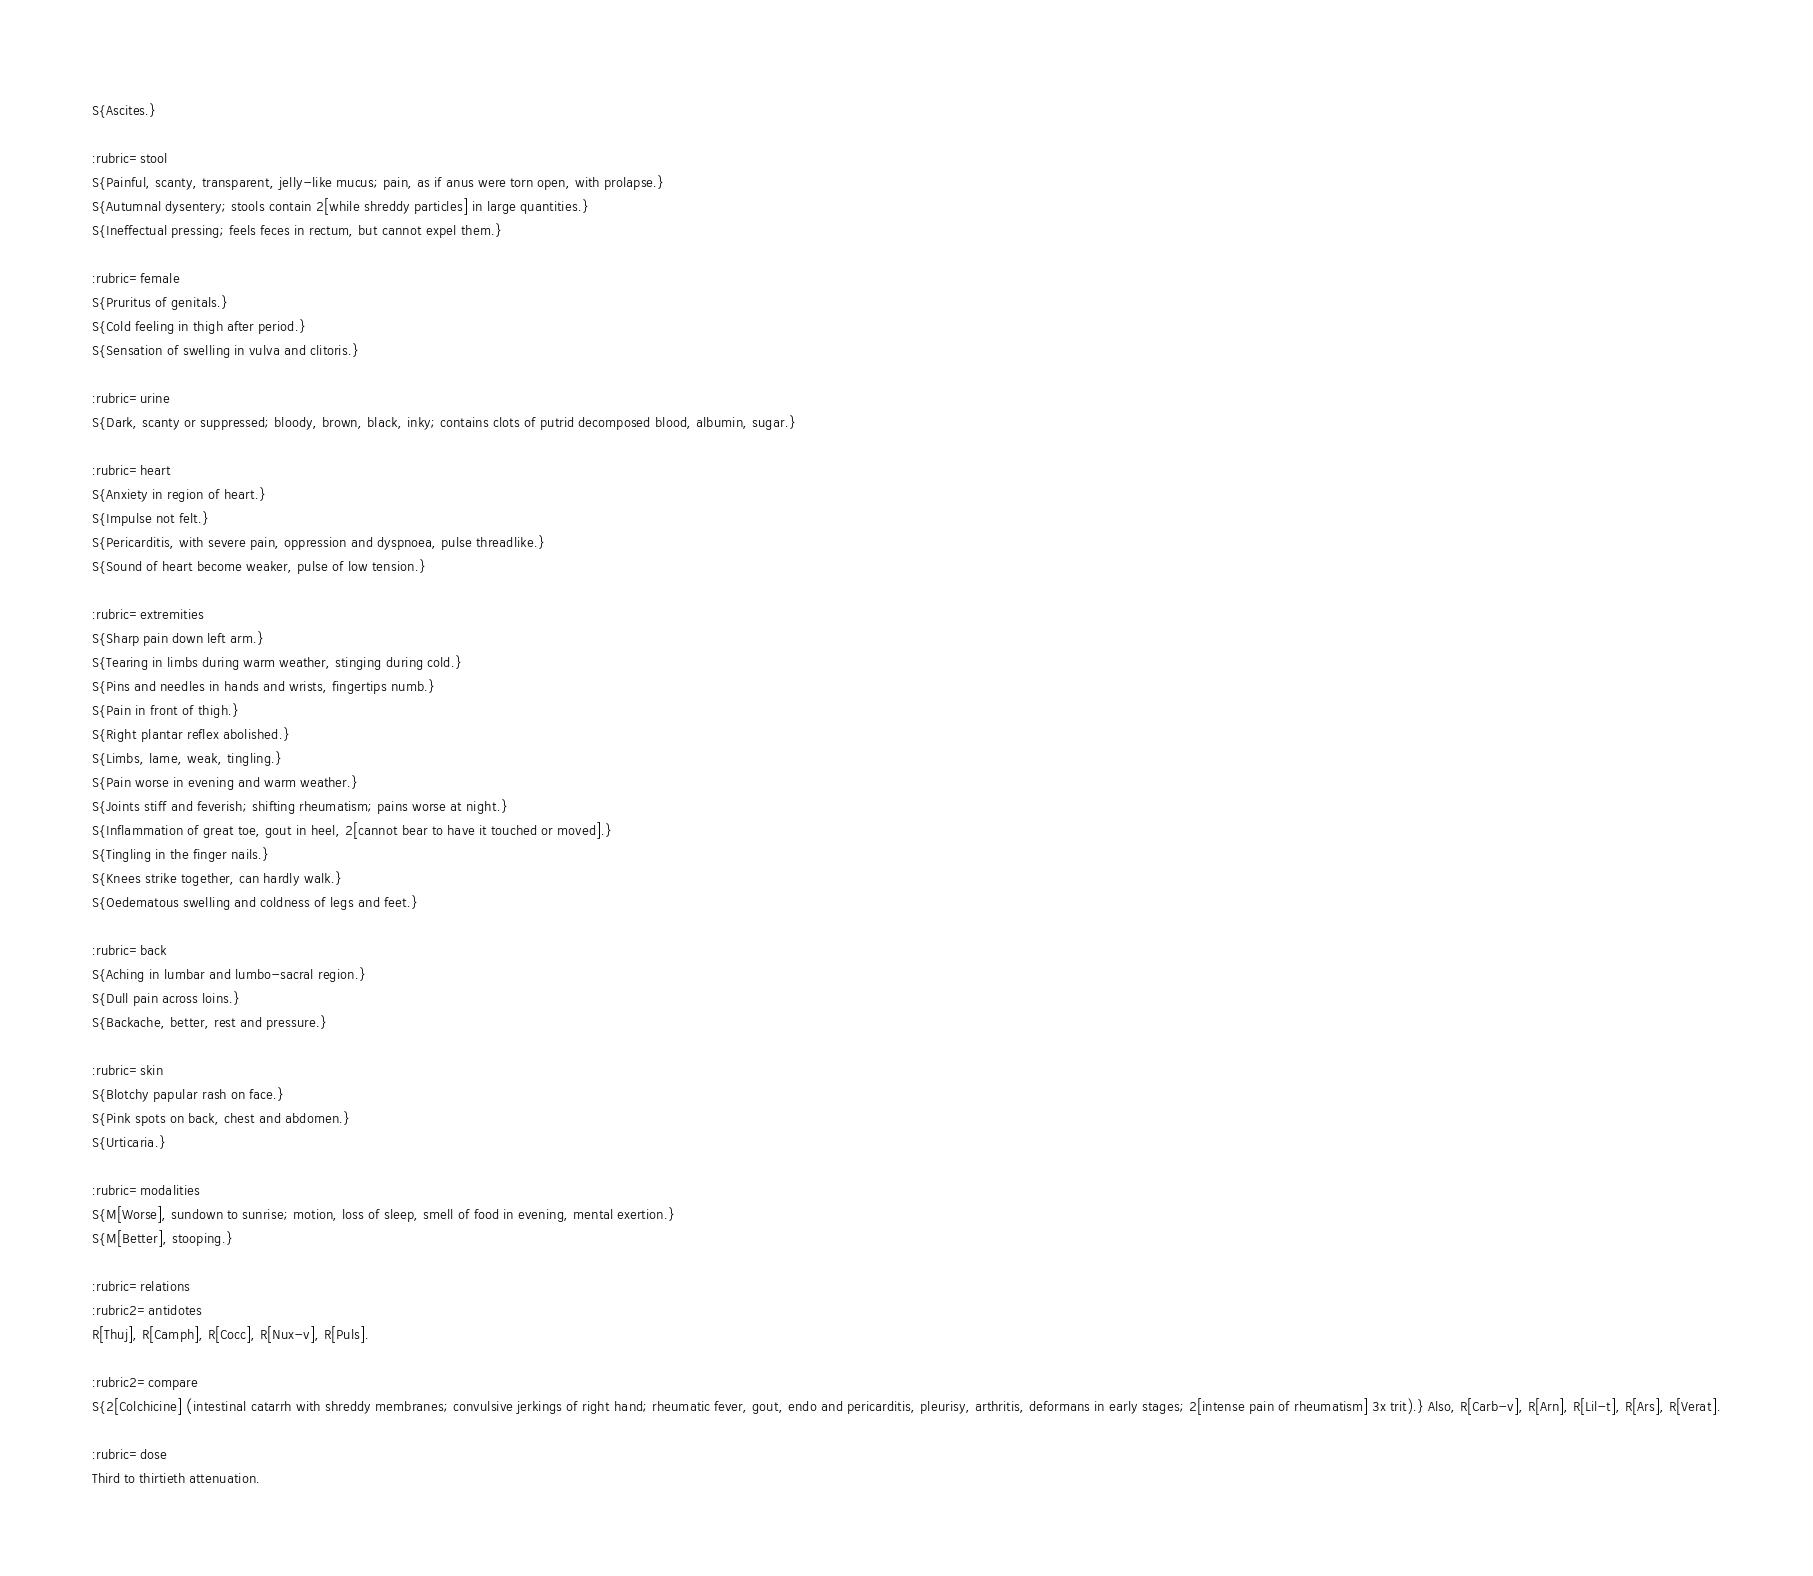<code> <loc_0><loc_0><loc_500><loc_500><_ObjectiveC_>S{Ascites.}

:rubric=stool
S{Painful, scanty, transparent, jelly-like mucus; pain, as if anus were torn open, with prolapse.}
S{Autumnal dysentery; stools contain 2[while shreddy particles] in large quantities.}
S{Ineffectual pressing; feels feces in rectum, but cannot expel them.}

:rubric=female
S{Pruritus of genitals.}
S{Cold feeling in thigh after period.}
S{Sensation of swelling in vulva and clitoris.}

:rubric=urine
S{Dark, scanty or suppressed; bloody, brown, black, inky; contains clots of putrid decomposed blood, albumin, sugar.}

:rubric=heart
S{Anxiety in region of heart.}
S{Impulse not felt.}
S{Pericarditis, with severe pain, oppression and dyspnoea, pulse threadlike.}
S{Sound of heart become weaker, pulse of low tension.}

:rubric=extremities
S{Sharp pain down left arm.}
S{Tearing in limbs during warm weather, stinging during cold.}
S{Pins and needles in hands and wrists, fingertips numb.}
S{Pain in front of thigh.}
S{Right plantar reflex abolished.}
S{Limbs, lame, weak, tingling.}
S{Pain worse in evening and warm weather.}
S{Joints stiff and feverish; shifting rheumatism; pains worse at night.}
S{Inflammation of great toe, gout in heel, 2[cannot bear to have it touched or moved].}
S{Tingling in the finger nails.}
S{Knees strike together, can hardly walk.}
S{Oedematous swelling and coldness of legs and feet.}

:rubric=back
S{Aching in lumbar and lumbo-sacral region.}
S{Dull pain across loins.}
S{Backache, better, rest and pressure.}

:rubric=skin
S{Blotchy papular rash on face.}
S{Pink spots on back, chest and abdomen.}
S{Urticaria.}

:rubric=modalities
S{M[Worse], sundown to sunrise; motion, loss of sleep, smell of food in evening, mental exertion.}
S{M[Better], stooping.}

:rubric=relations
:rubric2=antidotes
R[Thuj], R[Camph], R[Cocc], R[Nux-v], R[Puls].

:rubric2=compare
S{2[Colchicine] (intestinal catarrh with shreddy membranes; convulsive jerkings of right hand; rheumatic fever, gout, endo and pericarditis, pleurisy, arthritis, deformans in early stages; 2[intense pain of rheumatism] 3x trit).} Also, R[Carb-v], R[Arn], R[Lil-t], R[Ars], R[Verat].

:rubric=dose
Third to thirtieth attenuation.</code> 